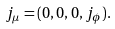Convert formula to latex. <formula><loc_0><loc_0><loc_500><loc_500>j _ { \mu } = ( 0 , 0 , 0 , j _ { \phi } ) .</formula> 